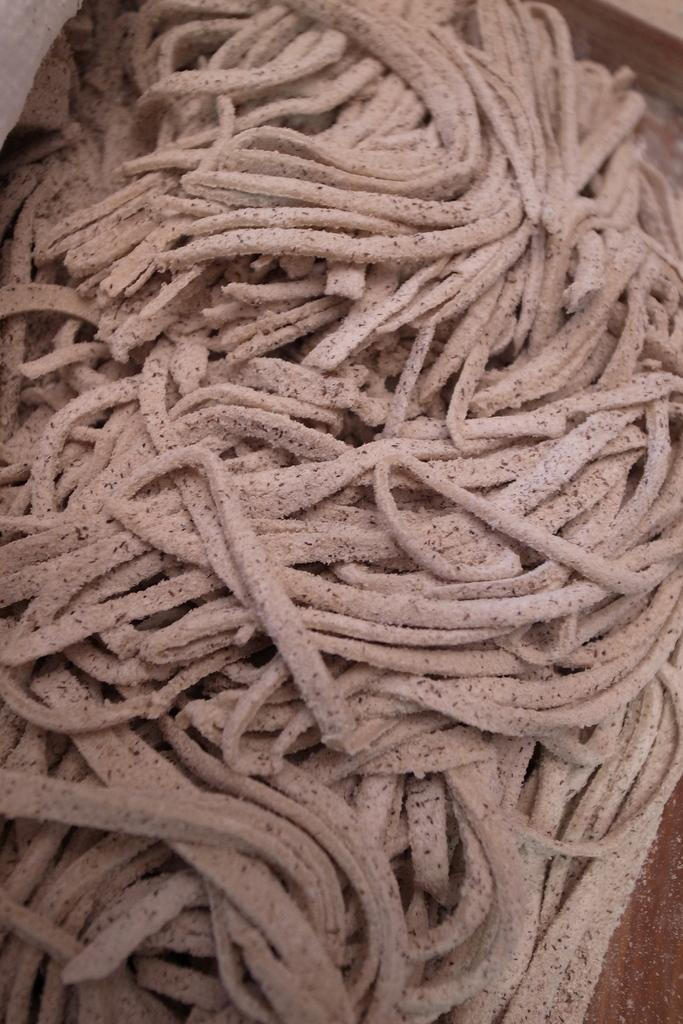What is the main subject of the image? The main subject of the image is a pile of flour strands. Where is the pile of flour strands located? The pile of flour strands is on a table. What type of quince can be seen in the image? There is no quince present in the image; it features a pile of flour strands on a table. What thrill can be experienced by the apple in the image? There is no apple present in the image, and therefore no thrill can be experienced by an apple. 